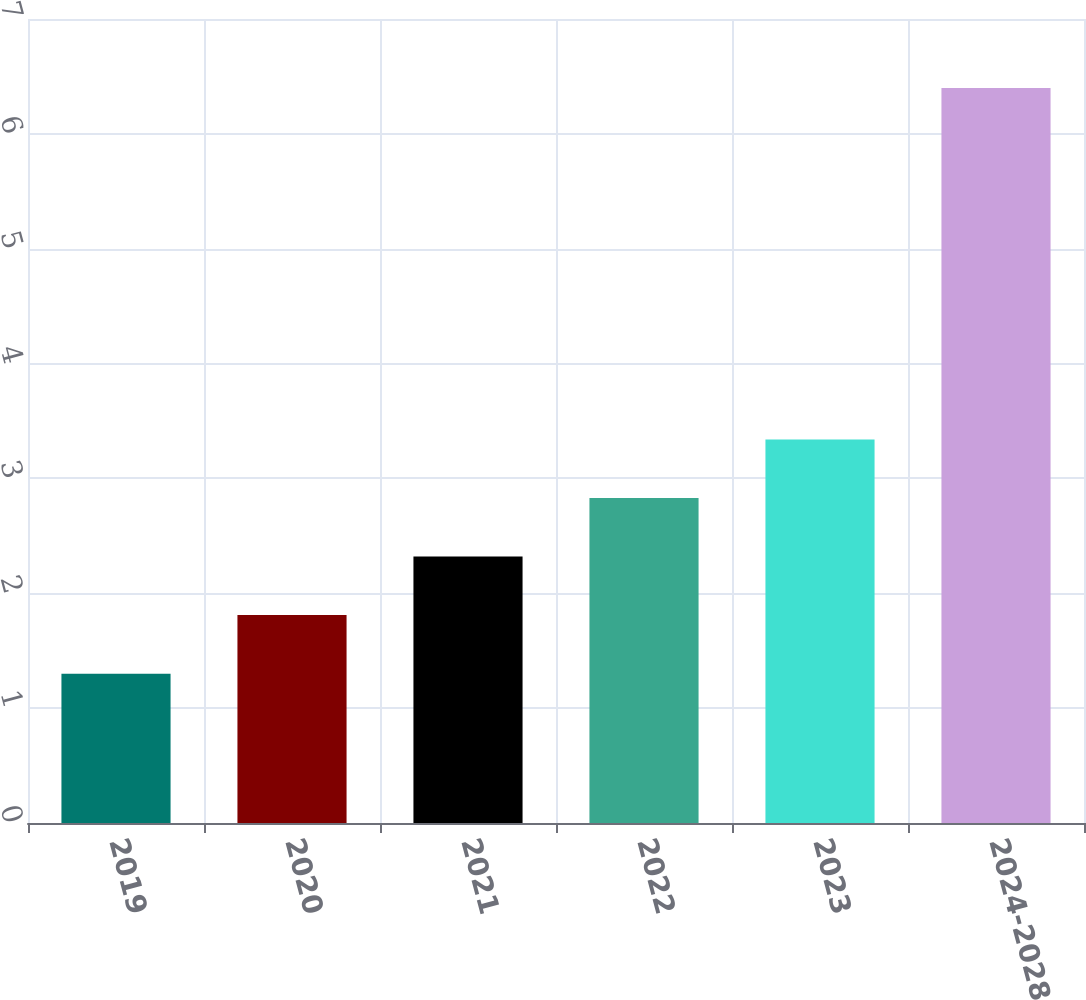Convert chart. <chart><loc_0><loc_0><loc_500><loc_500><bar_chart><fcel>2019<fcel>2020<fcel>2021<fcel>2022<fcel>2023<fcel>2024-2028<nl><fcel>1.3<fcel>1.81<fcel>2.32<fcel>2.83<fcel>3.34<fcel>6.4<nl></chart> 